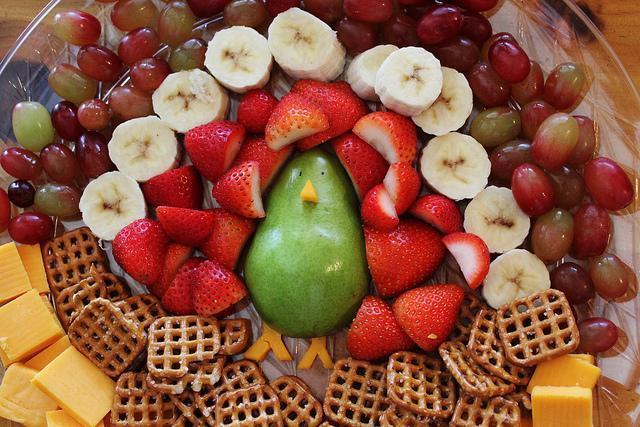How many bananas slices are there?
Give a very brief answer. 11. How many bananas are there?
Give a very brief answer. 3. 